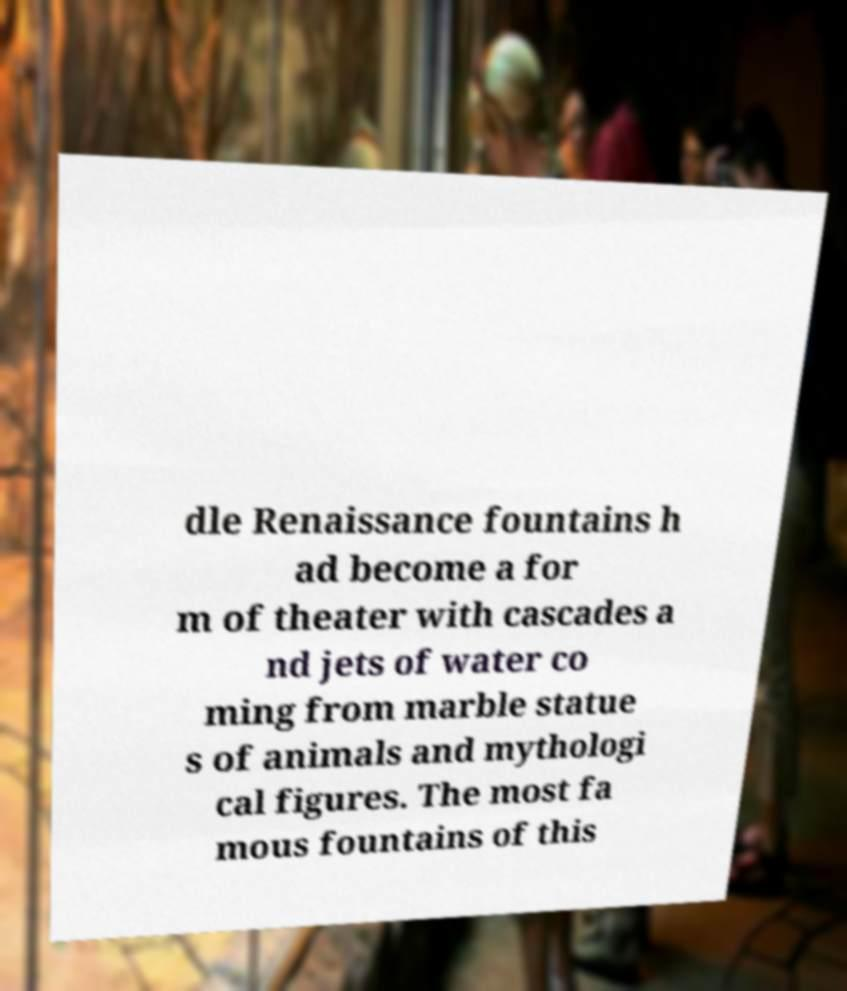Can you read and provide the text displayed in the image?This photo seems to have some interesting text. Can you extract and type it out for me? dle Renaissance fountains h ad become a for m of theater with cascades a nd jets of water co ming from marble statue s of animals and mythologi cal figures. The most fa mous fountains of this 